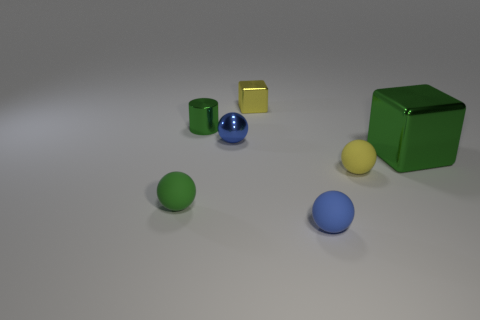Are there any other things that are the same color as the metallic cylinder? Yes, there is a small metallic cube that has the same golden hue as the cylinder. Both items share a similar reflective surface quality and color, indicating that they may be made of similar materials or are intended to be part of a set. 